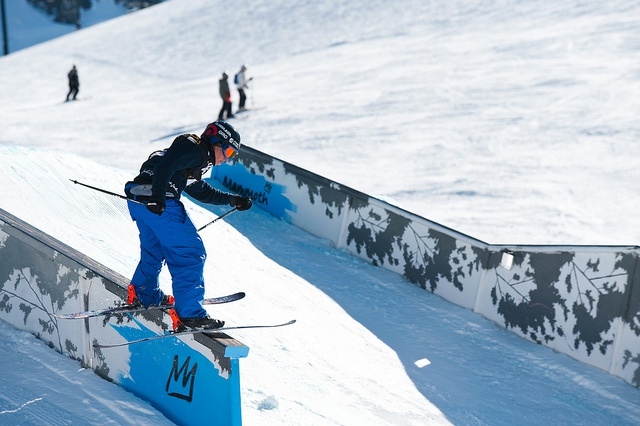Describe the objects in this image and their specific colors. I can see people in blue, black, navy, and darkblue tones, skis in blue, darkgray, gray, and lightgray tones, people in blue, black, darkblue, and gray tones, people in blue, darkgray, black, and gray tones, and people in blue, black, and gray tones in this image. 